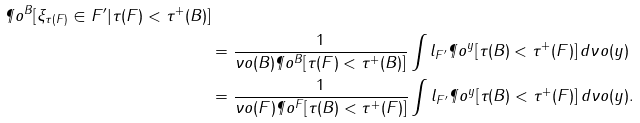Convert formula to latex. <formula><loc_0><loc_0><loc_500><loc_500>{ \P o ^ { B } [ \xi _ { \tau ( F ) } \in F ^ { \prime } | \tau ( F ) < \tau ^ { + } ( B ) ] } \\ & = \frac { 1 } { \nu o ( B ) \P o ^ { B } [ \tau ( F ) < \tau ^ { + } ( B ) ] } \int l _ { F ^ { \prime } } \P o ^ { y } [ \tau ( B ) < \tau ^ { + } ( F ) ] \, d \nu o ( y ) \\ & = \frac { 1 } { \nu o ( F ) \P o ^ { F } [ \tau ( B ) < \tau ^ { + } ( F ) ] } \int l _ { F ^ { \prime } } \P o ^ { y } [ \tau ( B ) < \tau ^ { + } ( F ) ] \, d \nu o ( y ) .</formula> 